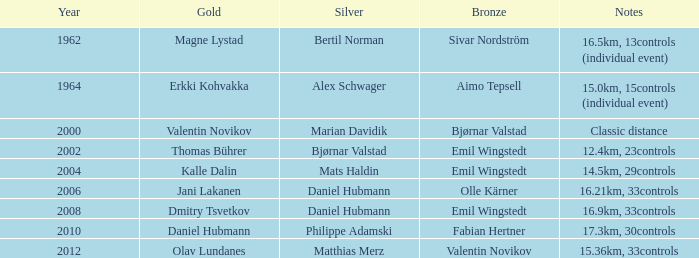Would you mind parsing the complete table? {'header': ['Year', 'Gold', 'Silver', 'Bronze', 'Notes'], 'rows': [['1962', 'Magne Lystad', 'Bertil Norman', 'Sivar Nordström', '16.5km, 13controls (individual event)'], ['1964', 'Erkki Kohvakka', 'Alex Schwager', 'Aimo Tepsell', '15.0km, 15controls (individual event)'], ['2000', 'Valentin Novikov', 'Marian Davidik', 'Bjørnar Valstad', 'Classic distance'], ['2002', 'Thomas Bührer', 'Bjørnar Valstad', 'Emil Wingstedt', '12.4km, 23controls'], ['2004', 'Kalle Dalin', 'Mats Haldin', 'Emil Wingstedt', '14.5km, 29controls'], ['2006', 'Jani Lakanen', 'Daniel Hubmann', 'Olle Kärner', '16.21km, 33controls'], ['2008', 'Dmitry Tsvetkov', 'Daniel Hubmann', 'Emil Wingstedt', '16.9km, 33controls'], ['2010', 'Daniel Hubmann', 'Philippe Adamski', 'Fabian Hertner', '17.3km, 30controls'], ['2012', 'Olav Lundanes', 'Matthias Merz', 'Valentin Novikov', '15.36km, 33controls']]} Which year is associated with a valentin novikov bronze? 2012.0. 